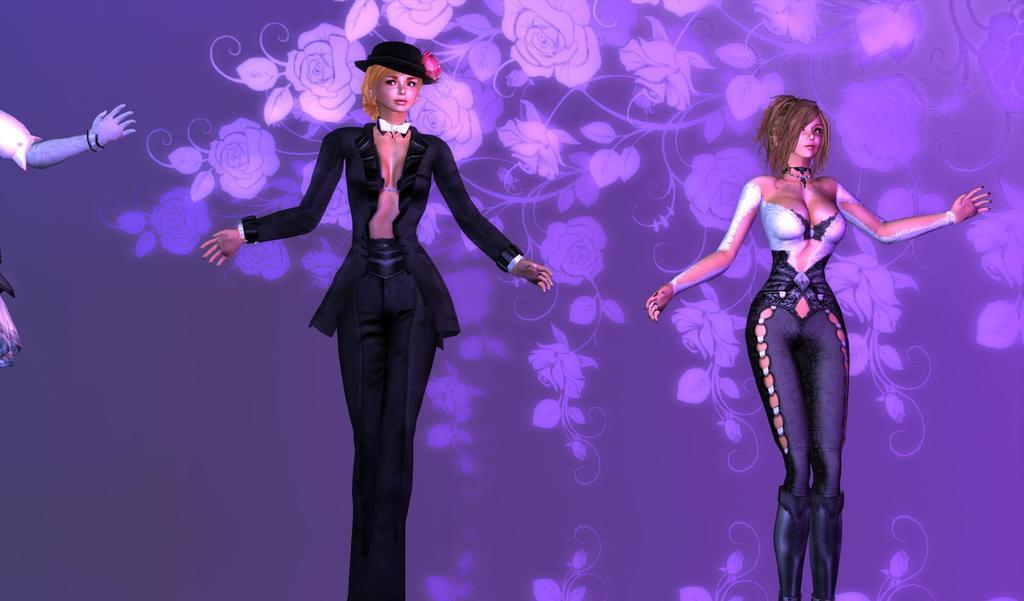In one or two sentences, can you explain what this image depicts? In the center of the image there are dolls. In the background we can see an art. 